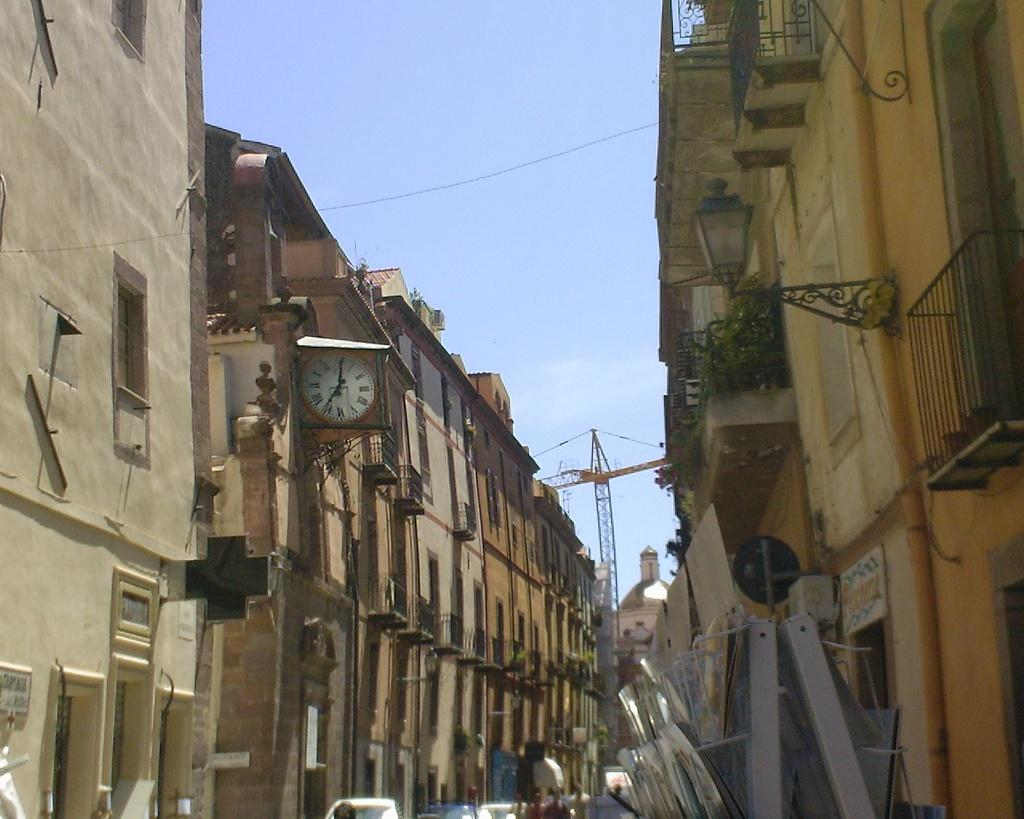What type of structures can be seen in the image? There are buildings in the image. What is located at the bottom of the image? There are cars and people at the bottom of the image. What is the large object in the center of the image? There is a crane in the center of the image. What is visible at the top of the image? The sky is visible at the top of the image. Can you see a blade being used by someone in the image? There is no blade or person using a blade present in the image. What type of rifle is being used by the person at the bottom of the image? There is no person or rifle present in the image. 